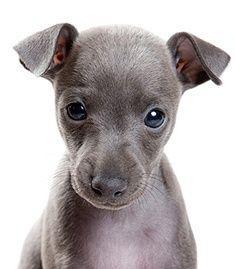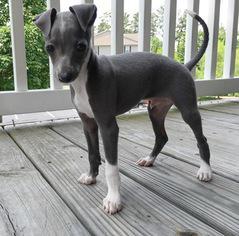The first image is the image on the left, the second image is the image on the right. Considering the images on both sides, is "There is a fence behind a dog." valid? Answer yes or no. Yes. 